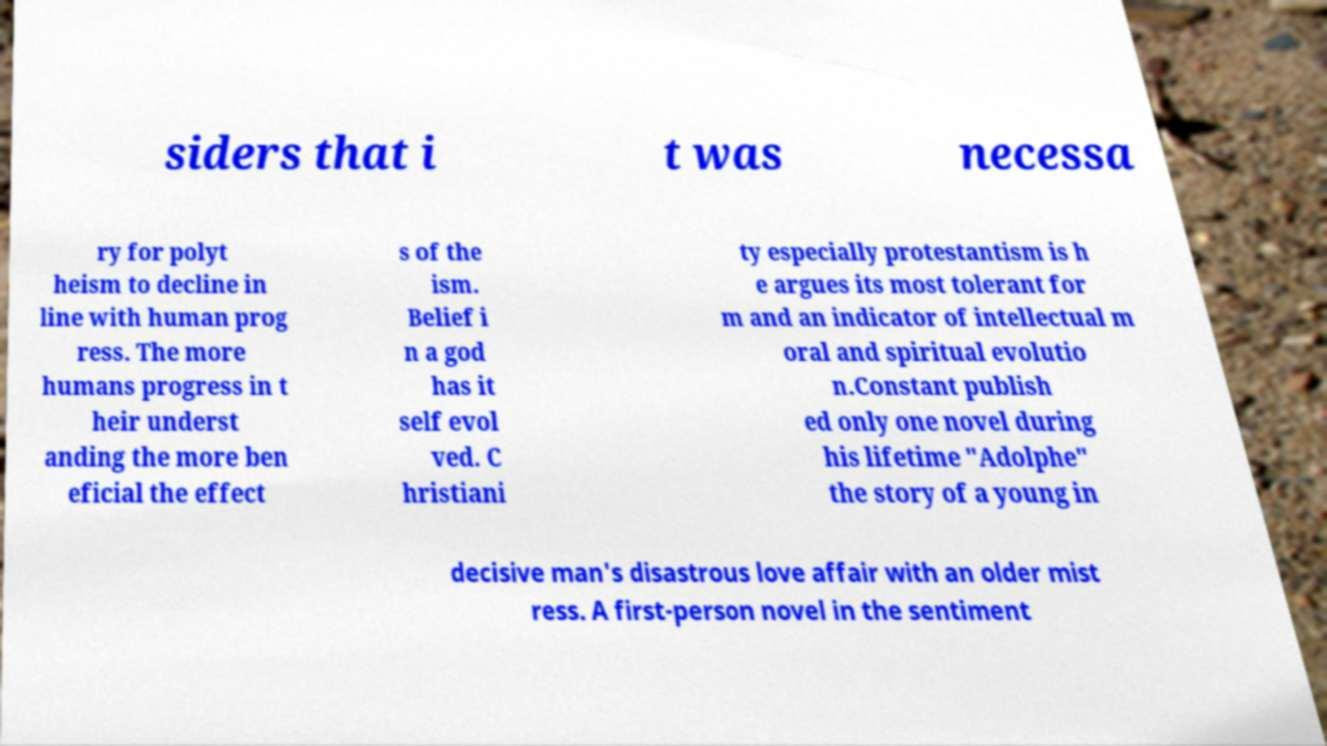Please identify and transcribe the text found in this image. siders that i t was necessa ry for polyt heism to decline in line with human prog ress. The more humans progress in t heir underst anding the more ben eficial the effect s of the ism. Belief i n a god has it self evol ved. C hristiani ty especially protestantism is h e argues its most tolerant for m and an indicator of intellectual m oral and spiritual evolutio n.Constant publish ed only one novel during his lifetime "Adolphe" the story of a young in decisive man's disastrous love affair with an older mist ress. A first-person novel in the sentiment 